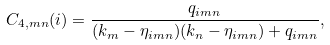<formula> <loc_0><loc_0><loc_500><loc_500>C _ { 4 , m n } ( i ) = \frac { q _ { i m n } } { ( k _ { m } - \eta _ { i m n } ) ( k _ { n } - \eta _ { i m n } ) + q _ { i m n } } ,</formula> 